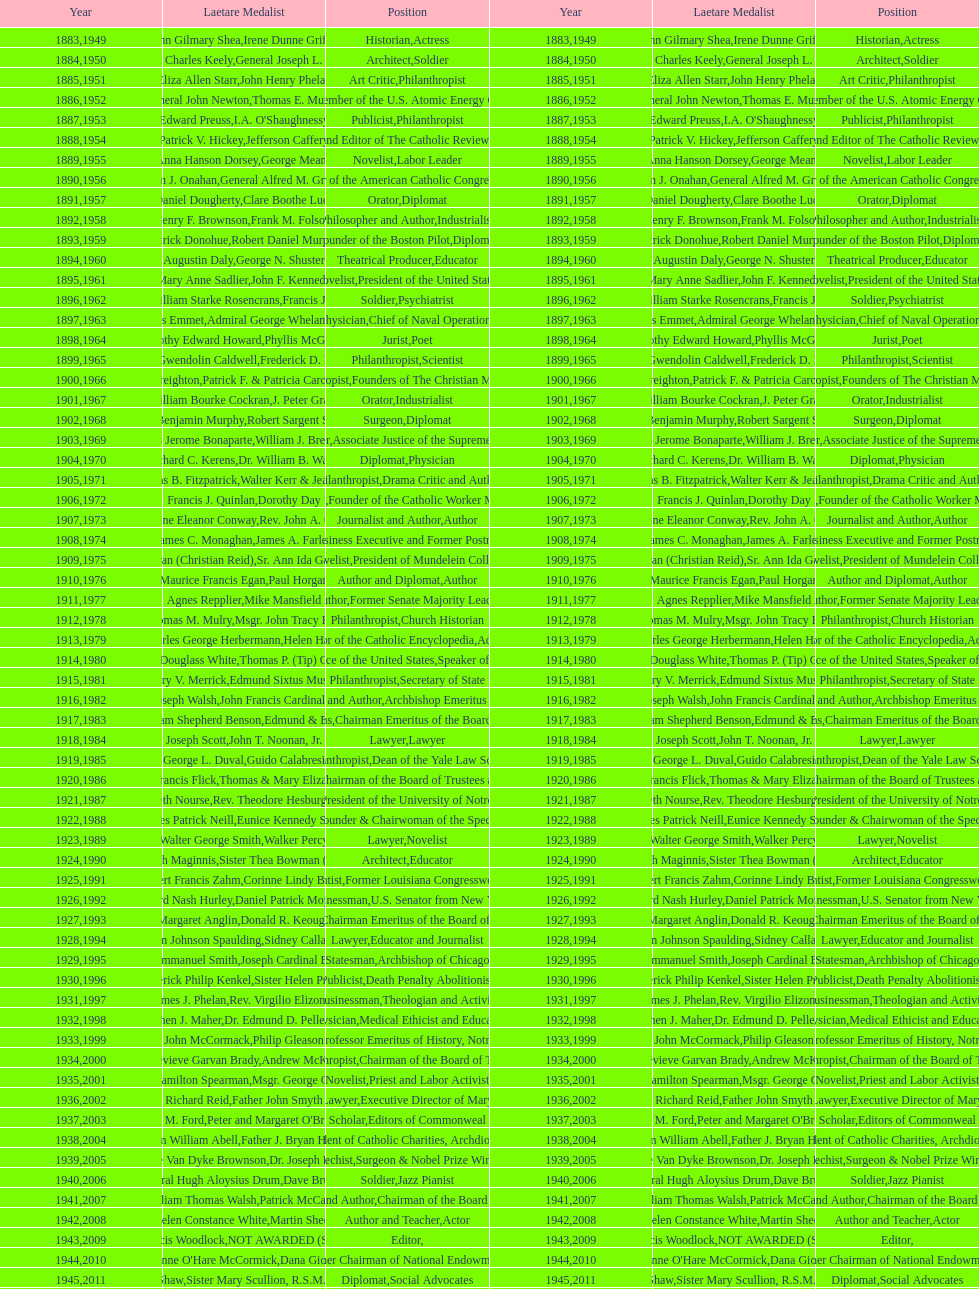What are the total number of times soldier is listed as the position on this chart? 4. 